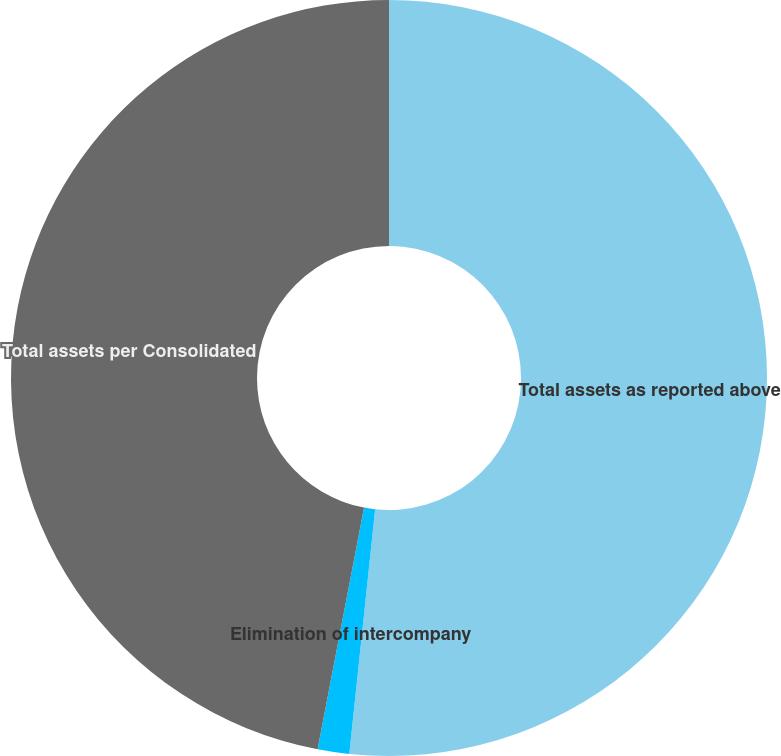Convert chart. <chart><loc_0><loc_0><loc_500><loc_500><pie_chart><fcel>Total assets as reported above<fcel>Elimination of intercompany<fcel>Total assets per Consolidated<nl><fcel>51.67%<fcel>1.35%<fcel>46.97%<nl></chart> 